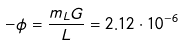Convert formula to latex. <formula><loc_0><loc_0><loc_500><loc_500>- \phi = \frac { m _ { L } G } { L } = 2 . 1 2 \cdot 1 0 ^ { - 6 }</formula> 